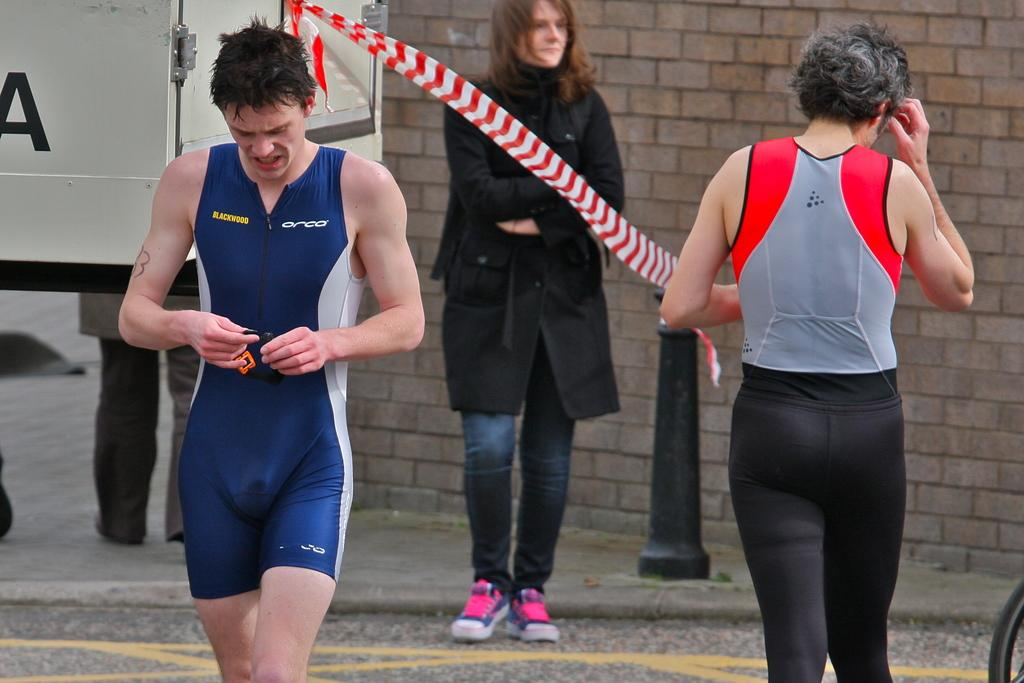Provide a one-sentence caption for the provided image. A man in a blue jumper with Blackwood on the chest. 